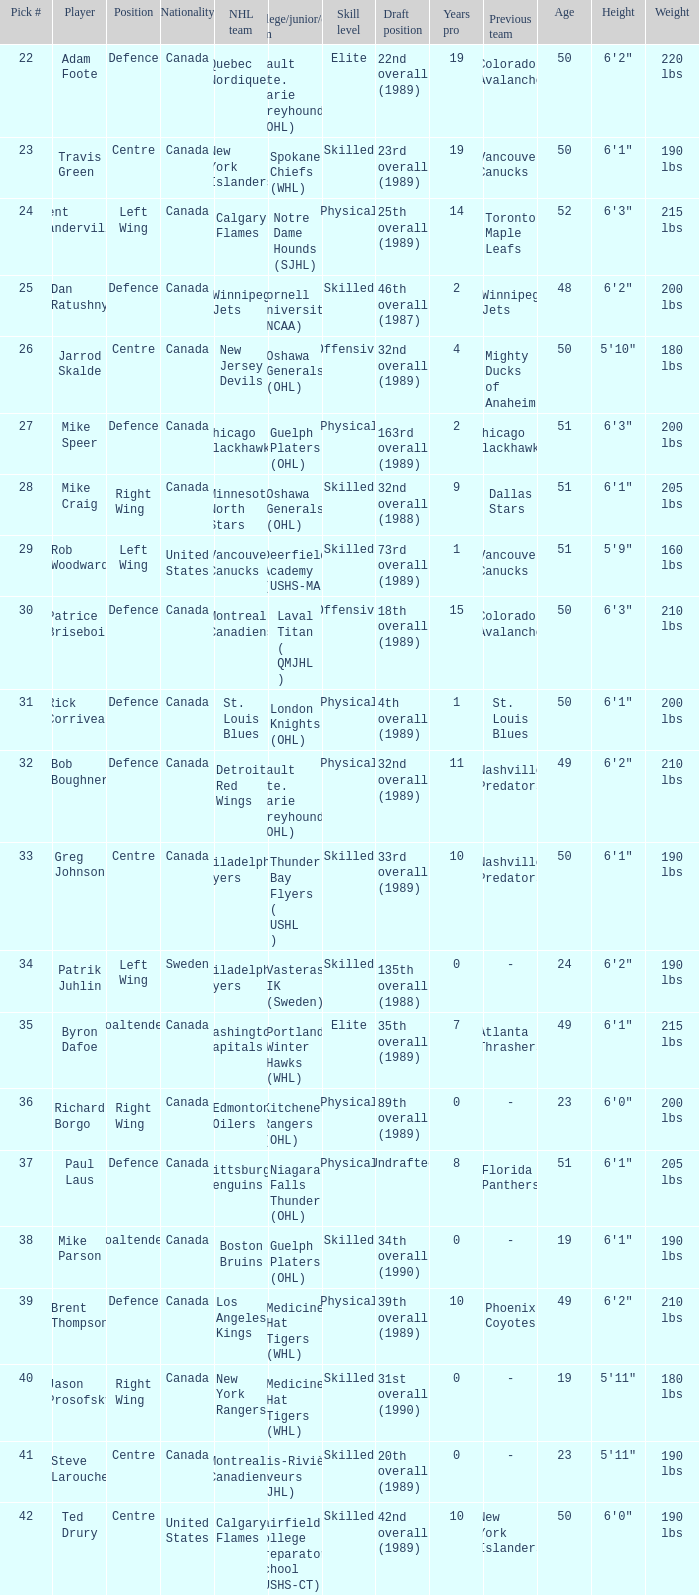What is the nationality of the draft pick player who plays centre position and is going to Calgary Flames? United States. 